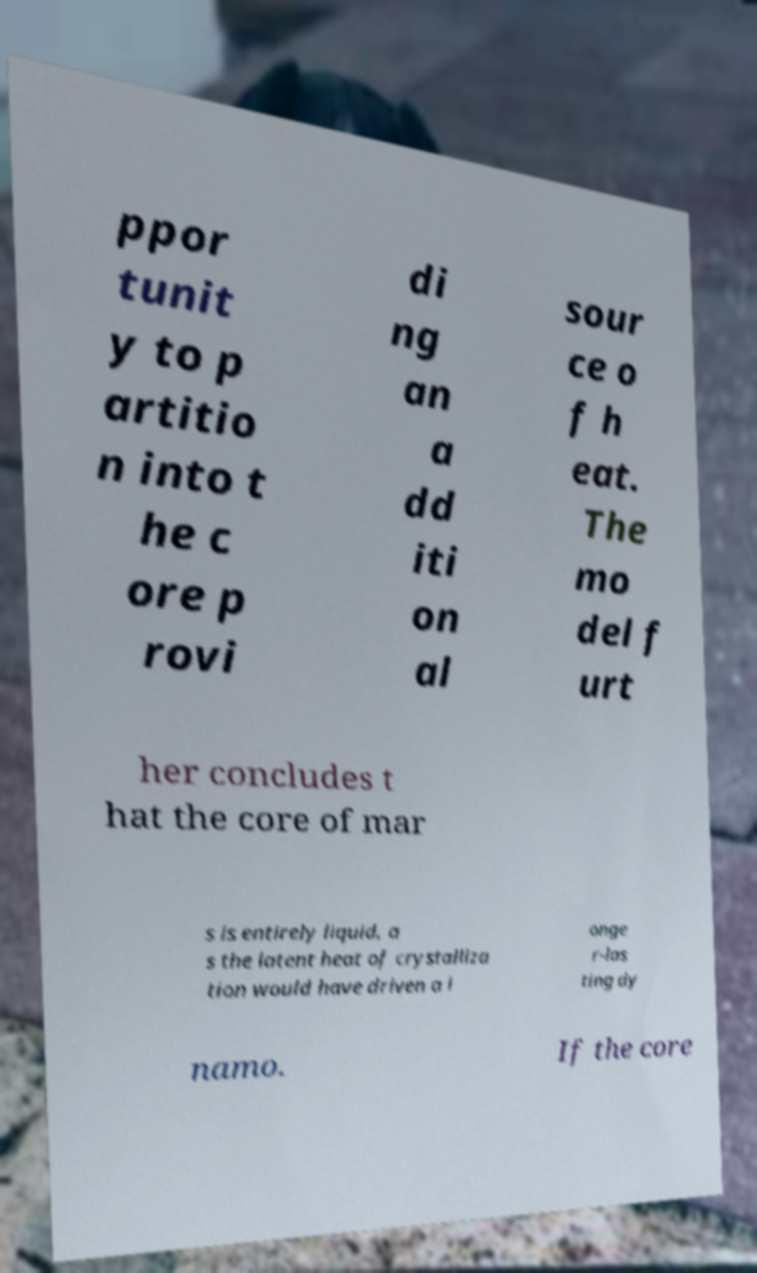Could you assist in decoding the text presented in this image and type it out clearly? ppor tunit y to p artitio n into t he c ore p rovi di ng an a dd iti on al sour ce o f h eat. The mo del f urt her concludes t hat the core of mar s is entirely liquid, a s the latent heat of crystalliza tion would have driven a l onge r-las ting dy namo. If the core 